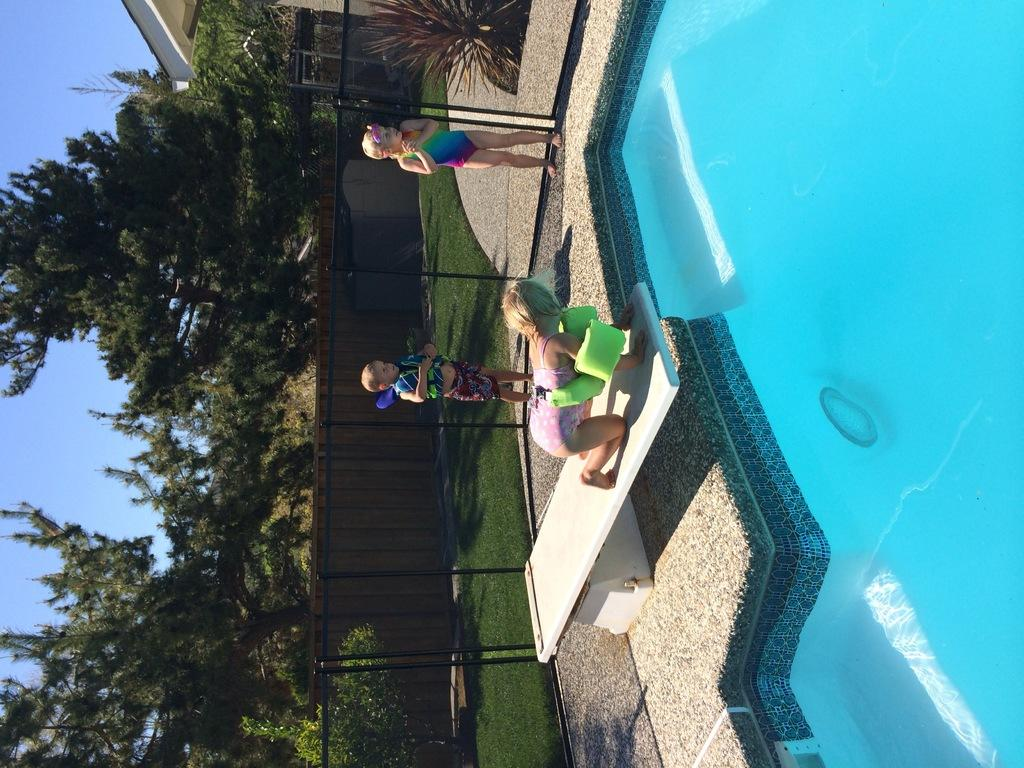How many children are in the image? There are three children in the image. What is the main feature in the background of the image? There is a swimming pool in the image. Can you describe any objects made of glass in the image? There is a glass object in the image. What type of barrier can be seen in the image? There is a fence in the image. What type of vegetation is present in the image? There are plants and trees in the image. What type of surface is present in the image? There is a stone platform in the image. What part of the natural environment is visible in the image? The sky is visible in the image. What type of crook is visible in the image? There is no crook present in the image. What type of beast can be seen interacting with the children in the image? There are no beasts present in the image; only the children, swimming pool, glass object, fence, plants, trees, stone platform, and sky are visible. 